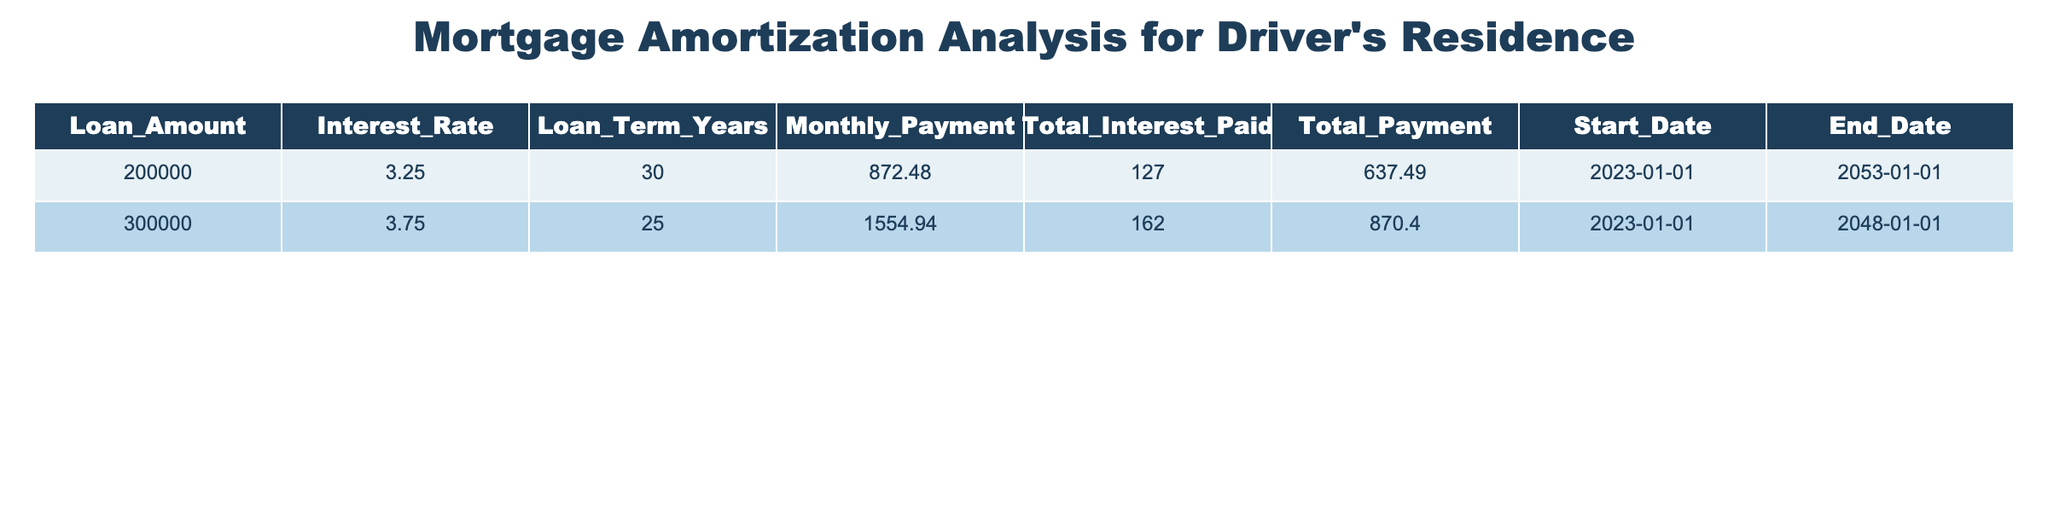What is the loan amount for the property with a 30-year term? The table shows two entries: one for a 30-year term with a loan amount of 200,000 and another entry for a different loan term. Therefore, the loan amount for the 30-year term is 200,000.
Answer: 200,000 What is the total payment for the 25-year mortgage? Looking at the second row in the table, the total payment for the mortgage with a 25-year term is listed as 162,870.40.
Answer: 162,870.40 Is the interest rate for the 30-year loan higher than the 25-year loan? The interest rate for the 30-year loan is 3.25%, while for the 25-year loan, it is 3.75%. Since 3.75% is greater than 3.25%, this statement is false.
Answer: No What is the difference in total interest paid between the two loans? The total interest for the first loan is 127,637.49, and for the second loan, it is 162,870.40. To find the difference, we subtract the first value from the second: 162,870.40 - 127,637.49 = 35,232.91.
Answer: 35,232.91 What is the average monthly payment across both loans? The monthly payments are 872.48 for the first loan and 1554.94 for the second loan. Adding them gives 872.48 + 1554.94 = 2427.42. To find the average, divide by the number of loans (2): 2427.42 / 2 = 1213.71.
Answer: 1213.71 Will the 30-year loan be paid off before the 25-year loan? The end date for the 30-year loan is 2053-01-01 and for the 25-year loan, it is 2048-01-01. Since the 30-year loan ends later, the statement is false.
Answer: No What is the total interest paid for both loans combined? The total interest paid for the first loan is 127,637.49 and for the second loan is 162,870.40. Adding these two amounts gives 127,637.49 + 162,870.40 = 290,507.89.
Answer: 290,507.89 